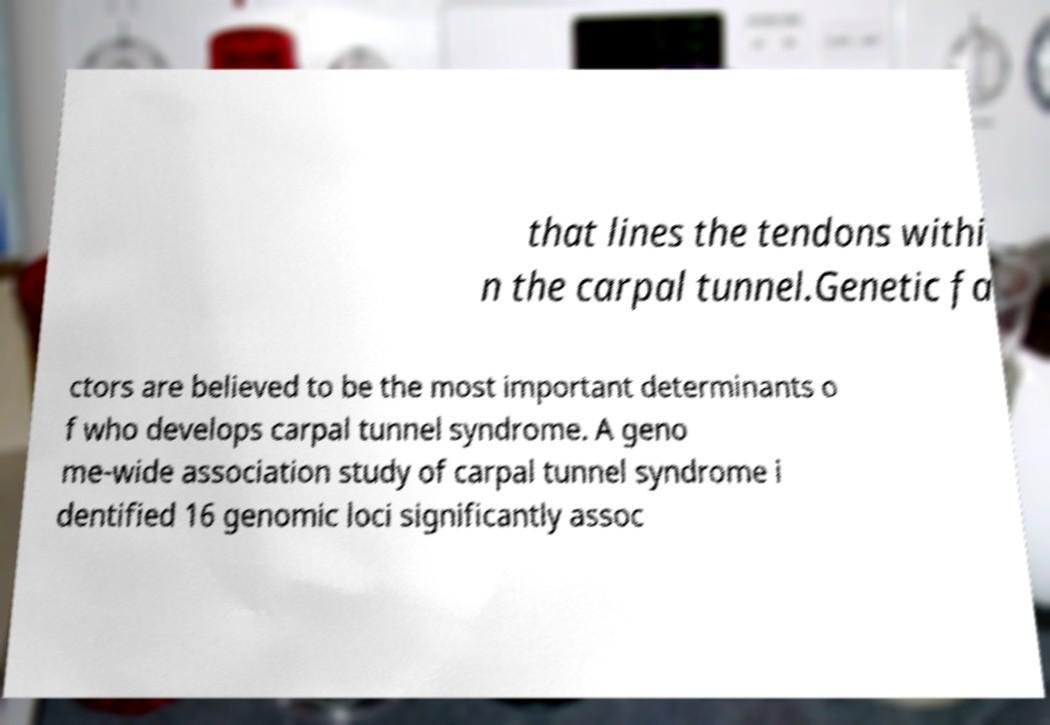What messages or text are displayed in this image? I need them in a readable, typed format. that lines the tendons withi n the carpal tunnel.Genetic fa ctors are believed to be the most important determinants o f who develops carpal tunnel syndrome. A geno me-wide association study of carpal tunnel syndrome i dentified 16 genomic loci significantly assoc 